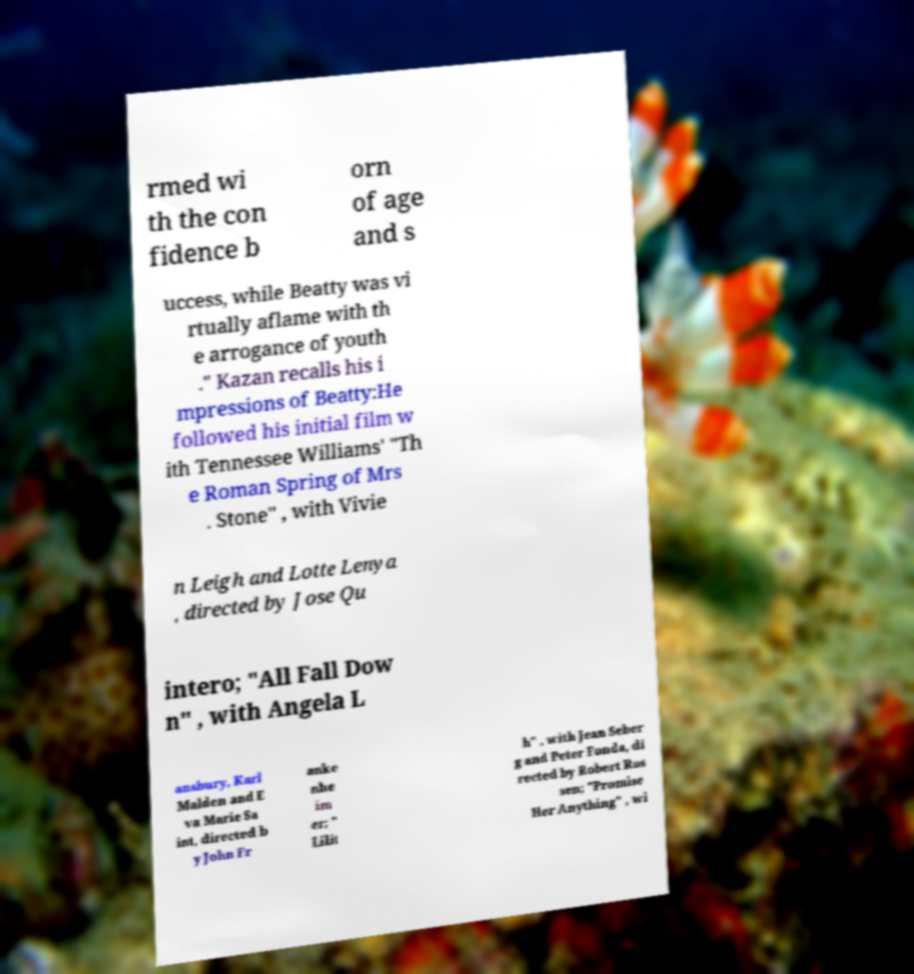Please identify and transcribe the text found in this image. rmed wi th the con fidence b orn of age and s uccess, while Beatty was vi rtually aflame with th e arrogance of youth ." Kazan recalls his i mpressions of Beatty:He followed his initial film w ith Tennessee Williams' "Th e Roman Spring of Mrs . Stone" , with Vivie n Leigh and Lotte Lenya , directed by Jose Qu intero; "All Fall Dow n" , with Angela L ansbury, Karl Malden and E va Marie Sa int, directed b y John Fr anke nhe im er; " Lilit h" , with Jean Seber g and Peter Fonda, di rected by Robert Ros sen; "Promise Her Anything" , wi 